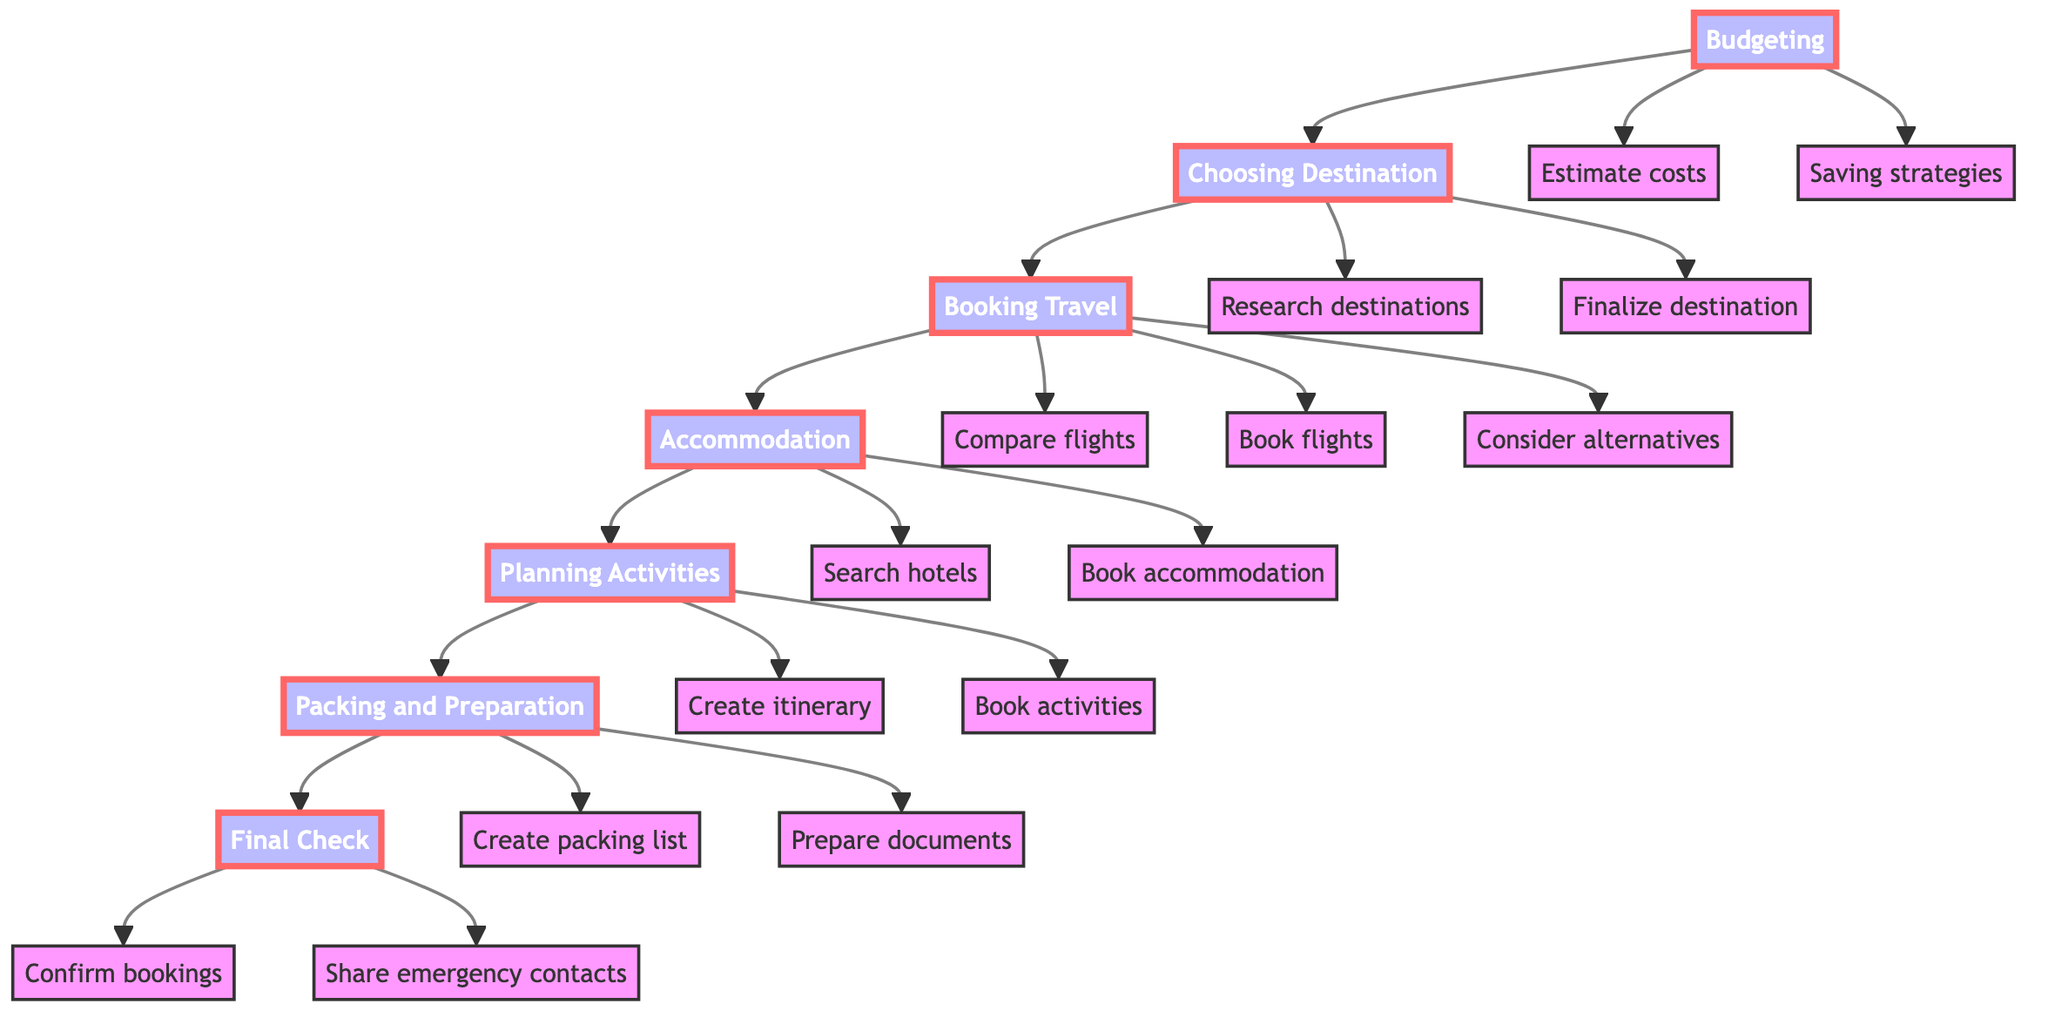What is the first step in planning a vacation? In the diagram, the first step listed in the flow is Budgeting, which initiates the planning process.
Answer: Budgeting How many main steps are there in the vacation planning process? By counting the nodes designated as main steps, there are a total of 7 main steps listed in the diagram.
Answer: 7 What follows the step of Booking Travel? Following Booking Travel in the diagram, the next step is Accommodation, indicating the sequential flow of planning activities.
Answer: Accommodation Which detail is related to the step of Accommodation? Under Accommodation, there are two specific details provided: Search hotels and Book accommodation, which are directly linked to this step in the diagram.
Answer: Search hotels, Book accommodation What should you do after Packing and Preparation? After completing Packing and Preparation, the subsequent step in the flow is Final Check, indicating the last phase of the vacation planning process.
Answer: Final Check How many details are associated with the step of Planning Activities? The step of Planning Activities has two details outlined: Create itinerary and Book activities, which accounts for all details related to this step in the diagram.
Answer: 2 What is a reason to research destinations according to the diagram? The diagram indicates that researching destinations is important for considerations regarding weather, attractions, and safety, which are fundamental aspects when choosing a vacation spot.
Answer: Weather, attractions, safety What is the detail associated with the step of Budgeting that focuses on financial management? The detail related to financial management under Budgeting is Saving strategies, which provides guidance on managing funds efficiently throughout the planning process.
Answer: Saving strategies What is confirmed during the Final Check step? During the Final Check step, confirming bookings is a critical action that ensures all necessary arrangements (flights, accommodation, activities) are in order before traveling.
Answer: Confirm bookings 